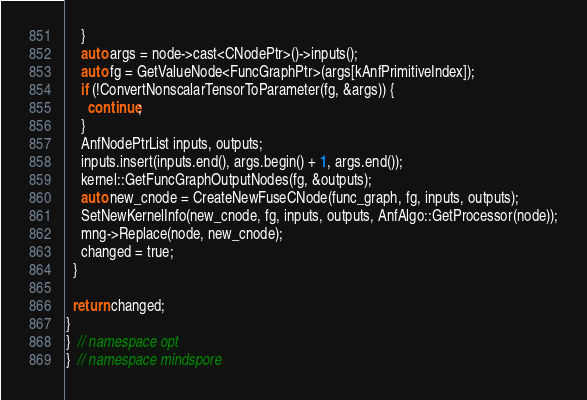Convert code to text. <code><loc_0><loc_0><loc_500><loc_500><_C++_>    }
    auto args = node->cast<CNodePtr>()->inputs();
    auto fg = GetValueNode<FuncGraphPtr>(args[kAnfPrimitiveIndex]);
    if (!ConvertNonscalarTensorToParameter(fg, &args)) {
      continue;
    }
    AnfNodePtrList inputs, outputs;
    inputs.insert(inputs.end(), args.begin() + 1, args.end());
    kernel::GetFuncGraphOutputNodes(fg, &outputs);
    auto new_cnode = CreateNewFuseCNode(func_graph, fg, inputs, outputs);
    SetNewKernelInfo(new_cnode, fg, inputs, outputs, AnfAlgo::GetProcessor(node));
    mng->Replace(node, new_cnode);
    changed = true;
  }

  return changed;
}
}  // namespace opt
}  // namespace mindspore
</code> 